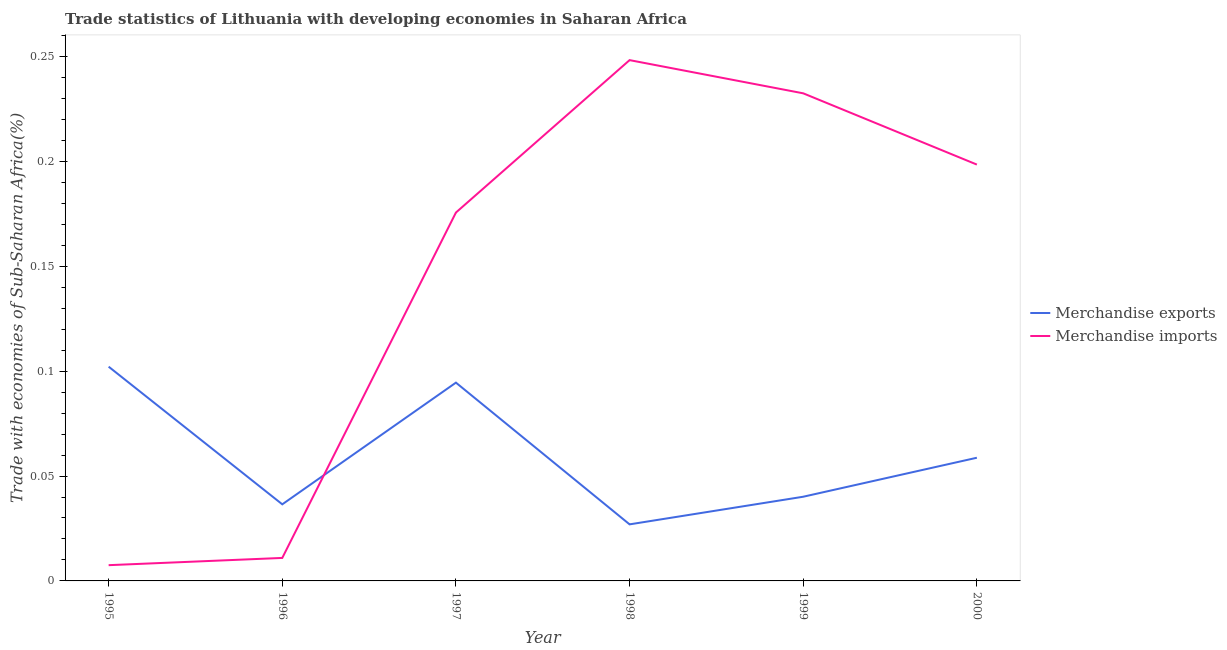How many different coloured lines are there?
Provide a short and direct response. 2. What is the merchandise exports in 1999?
Your answer should be very brief. 0.04. Across all years, what is the maximum merchandise imports?
Offer a terse response. 0.25. Across all years, what is the minimum merchandise exports?
Offer a terse response. 0.03. In which year was the merchandise exports minimum?
Give a very brief answer. 1998. What is the total merchandise exports in the graph?
Give a very brief answer. 0.36. What is the difference between the merchandise imports in 1995 and that in 1997?
Your answer should be compact. -0.17. What is the difference between the merchandise imports in 2000 and the merchandise exports in 1996?
Provide a succinct answer. 0.16. What is the average merchandise exports per year?
Make the answer very short. 0.06. In the year 2000, what is the difference between the merchandise imports and merchandise exports?
Offer a very short reply. 0.14. In how many years, is the merchandise exports greater than 0.22 %?
Your answer should be compact. 0. What is the ratio of the merchandise exports in 1997 to that in 1998?
Provide a succinct answer. 3.51. What is the difference between the highest and the second highest merchandise imports?
Ensure brevity in your answer.  0.02. What is the difference between the highest and the lowest merchandise imports?
Make the answer very short. 0.24. In how many years, is the merchandise exports greater than the average merchandise exports taken over all years?
Your answer should be very brief. 2. Is the sum of the merchandise imports in 1999 and 2000 greater than the maximum merchandise exports across all years?
Make the answer very short. Yes. Does the merchandise exports monotonically increase over the years?
Keep it short and to the point. No. Is the merchandise exports strictly greater than the merchandise imports over the years?
Make the answer very short. No. Is the merchandise exports strictly less than the merchandise imports over the years?
Offer a very short reply. No. How many years are there in the graph?
Your answer should be compact. 6. What is the difference between two consecutive major ticks on the Y-axis?
Your answer should be very brief. 0.05. Where does the legend appear in the graph?
Offer a terse response. Center right. How many legend labels are there?
Provide a short and direct response. 2. What is the title of the graph?
Ensure brevity in your answer.  Trade statistics of Lithuania with developing economies in Saharan Africa. Does "International Visitors" appear as one of the legend labels in the graph?
Offer a very short reply. No. What is the label or title of the X-axis?
Provide a short and direct response. Year. What is the label or title of the Y-axis?
Your answer should be compact. Trade with economies of Sub-Saharan Africa(%). What is the Trade with economies of Sub-Saharan Africa(%) in Merchandise exports in 1995?
Your answer should be compact. 0.1. What is the Trade with economies of Sub-Saharan Africa(%) in Merchandise imports in 1995?
Offer a very short reply. 0.01. What is the Trade with economies of Sub-Saharan Africa(%) of Merchandise exports in 1996?
Offer a very short reply. 0.04. What is the Trade with economies of Sub-Saharan Africa(%) of Merchandise imports in 1996?
Your response must be concise. 0.01. What is the Trade with economies of Sub-Saharan Africa(%) of Merchandise exports in 1997?
Your answer should be compact. 0.09. What is the Trade with economies of Sub-Saharan Africa(%) of Merchandise imports in 1997?
Ensure brevity in your answer.  0.18. What is the Trade with economies of Sub-Saharan Africa(%) of Merchandise exports in 1998?
Provide a short and direct response. 0.03. What is the Trade with economies of Sub-Saharan Africa(%) of Merchandise imports in 1998?
Your response must be concise. 0.25. What is the Trade with economies of Sub-Saharan Africa(%) of Merchandise exports in 1999?
Your answer should be compact. 0.04. What is the Trade with economies of Sub-Saharan Africa(%) in Merchandise imports in 1999?
Your answer should be very brief. 0.23. What is the Trade with economies of Sub-Saharan Africa(%) in Merchandise exports in 2000?
Offer a terse response. 0.06. What is the Trade with economies of Sub-Saharan Africa(%) of Merchandise imports in 2000?
Ensure brevity in your answer.  0.2. Across all years, what is the maximum Trade with economies of Sub-Saharan Africa(%) in Merchandise exports?
Keep it short and to the point. 0.1. Across all years, what is the maximum Trade with economies of Sub-Saharan Africa(%) in Merchandise imports?
Your response must be concise. 0.25. Across all years, what is the minimum Trade with economies of Sub-Saharan Africa(%) of Merchandise exports?
Ensure brevity in your answer.  0.03. Across all years, what is the minimum Trade with economies of Sub-Saharan Africa(%) in Merchandise imports?
Your answer should be very brief. 0.01. What is the total Trade with economies of Sub-Saharan Africa(%) in Merchandise exports in the graph?
Provide a short and direct response. 0.36. What is the total Trade with economies of Sub-Saharan Africa(%) in Merchandise imports in the graph?
Give a very brief answer. 0.87. What is the difference between the Trade with economies of Sub-Saharan Africa(%) of Merchandise exports in 1995 and that in 1996?
Your response must be concise. 0.07. What is the difference between the Trade with economies of Sub-Saharan Africa(%) in Merchandise imports in 1995 and that in 1996?
Your answer should be compact. -0. What is the difference between the Trade with economies of Sub-Saharan Africa(%) of Merchandise exports in 1995 and that in 1997?
Make the answer very short. 0.01. What is the difference between the Trade with economies of Sub-Saharan Africa(%) in Merchandise imports in 1995 and that in 1997?
Provide a short and direct response. -0.17. What is the difference between the Trade with economies of Sub-Saharan Africa(%) of Merchandise exports in 1995 and that in 1998?
Provide a short and direct response. 0.08. What is the difference between the Trade with economies of Sub-Saharan Africa(%) in Merchandise imports in 1995 and that in 1998?
Provide a short and direct response. -0.24. What is the difference between the Trade with economies of Sub-Saharan Africa(%) in Merchandise exports in 1995 and that in 1999?
Give a very brief answer. 0.06. What is the difference between the Trade with economies of Sub-Saharan Africa(%) in Merchandise imports in 1995 and that in 1999?
Your response must be concise. -0.22. What is the difference between the Trade with economies of Sub-Saharan Africa(%) in Merchandise exports in 1995 and that in 2000?
Your response must be concise. 0.04. What is the difference between the Trade with economies of Sub-Saharan Africa(%) of Merchandise imports in 1995 and that in 2000?
Give a very brief answer. -0.19. What is the difference between the Trade with economies of Sub-Saharan Africa(%) of Merchandise exports in 1996 and that in 1997?
Provide a succinct answer. -0.06. What is the difference between the Trade with economies of Sub-Saharan Africa(%) in Merchandise imports in 1996 and that in 1997?
Provide a short and direct response. -0.16. What is the difference between the Trade with economies of Sub-Saharan Africa(%) in Merchandise exports in 1996 and that in 1998?
Provide a succinct answer. 0.01. What is the difference between the Trade with economies of Sub-Saharan Africa(%) of Merchandise imports in 1996 and that in 1998?
Offer a terse response. -0.24. What is the difference between the Trade with economies of Sub-Saharan Africa(%) of Merchandise exports in 1996 and that in 1999?
Your answer should be very brief. -0. What is the difference between the Trade with economies of Sub-Saharan Africa(%) of Merchandise imports in 1996 and that in 1999?
Keep it short and to the point. -0.22. What is the difference between the Trade with economies of Sub-Saharan Africa(%) of Merchandise exports in 1996 and that in 2000?
Provide a succinct answer. -0.02. What is the difference between the Trade with economies of Sub-Saharan Africa(%) of Merchandise imports in 1996 and that in 2000?
Provide a short and direct response. -0.19. What is the difference between the Trade with economies of Sub-Saharan Africa(%) of Merchandise exports in 1997 and that in 1998?
Offer a terse response. 0.07. What is the difference between the Trade with economies of Sub-Saharan Africa(%) in Merchandise imports in 1997 and that in 1998?
Make the answer very short. -0.07. What is the difference between the Trade with economies of Sub-Saharan Africa(%) in Merchandise exports in 1997 and that in 1999?
Offer a very short reply. 0.05. What is the difference between the Trade with economies of Sub-Saharan Africa(%) of Merchandise imports in 1997 and that in 1999?
Offer a very short reply. -0.06. What is the difference between the Trade with economies of Sub-Saharan Africa(%) in Merchandise exports in 1997 and that in 2000?
Your response must be concise. 0.04. What is the difference between the Trade with economies of Sub-Saharan Africa(%) in Merchandise imports in 1997 and that in 2000?
Your answer should be very brief. -0.02. What is the difference between the Trade with economies of Sub-Saharan Africa(%) of Merchandise exports in 1998 and that in 1999?
Give a very brief answer. -0.01. What is the difference between the Trade with economies of Sub-Saharan Africa(%) in Merchandise imports in 1998 and that in 1999?
Your answer should be compact. 0.02. What is the difference between the Trade with economies of Sub-Saharan Africa(%) of Merchandise exports in 1998 and that in 2000?
Your answer should be compact. -0.03. What is the difference between the Trade with economies of Sub-Saharan Africa(%) of Merchandise imports in 1998 and that in 2000?
Give a very brief answer. 0.05. What is the difference between the Trade with economies of Sub-Saharan Africa(%) in Merchandise exports in 1999 and that in 2000?
Your answer should be very brief. -0.02. What is the difference between the Trade with economies of Sub-Saharan Africa(%) in Merchandise imports in 1999 and that in 2000?
Your answer should be very brief. 0.03. What is the difference between the Trade with economies of Sub-Saharan Africa(%) in Merchandise exports in 1995 and the Trade with economies of Sub-Saharan Africa(%) in Merchandise imports in 1996?
Ensure brevity in your answer.  0.09. What is the difference between the Trade with economies of Sub-Saharan Africa(%) in Merchandise exports in 1995 and the Trade with economies of Sub-Saharan Africa(%) in Merchandise imports in 1997?
Your response must be concise. -0.07. What is the difference between the Trade with economies of Sub-Saharan Africa(%) in Merchandise exports in 1995 and the Trade with economies of Sub-Saharan Africa(%) in Merchandise imports in 1998?
Offer a very short reply. -0.15. What is the difference between the Trade with economies of Sub-Saharan Africa(%) of Merchandise exports in 1995 and the Trade with economies of Sub-Saharan Africa(%) of Merchandise imports in 1999?
Give a very brief answer. -0.13. What is the difference between the Trade with economies of Sub-Saharan Africa(%) in Merchandise exports in 1995 and the Trade with economies of Sub-Saharan Africa(%) in Merchandise imports in 2000?
Provide a short and direct response. -0.1. What is the difference between the Trade with economies of Sub-Saharan Africa(%) in Merchandise exports in 1996 and the Trade with economies of Sub-Saharan Africa(%) in Merchandise imports in 1997?
Offer a very short reply. -0.14. What is the difference between the Trade with economies of Sub-Saharan Africa(%) of Merchandise exports in 1996 and the Trade with economies of Sub-Saharan Africa(%) of Merchandise imports in 1998?
Offer a terse response. -0.21. What is the difference between the Trade with economies of Sub-Saharan Africa(%) of Merchandise exports in 1996 and the Trade with economies of Sub-Saharan Africa(%) of Merchandise imports in 1999?
Make the answer very short. -0.2. What is the difference between the Trade with economies of Sub-Saharan Africa(%) in Merchandise exports in 1996 and the Trade with economies of Sub-Saharan Africa(%) in Merchandise imports in 2000?
Make the answer very short. -0.16. What is the difference between the Trade with economies of Sub-Saharan Africa(%) in Merchandise exports in 1997 and the Trade with economies of Sub-Saharan Africa(%) in Merchandise imports in 1998?
Make the answer very short. -0.15. What is the difference between the Trade with economies of Sub-Saharan Africa(%) of Merchandise exports in 1997 and the Trade with economies of Sub-Saharan Africa(%) of Merchandise imports in 1999?
Offer a terse response. -0.14. What is the difference between the Trade with economies of Sub-Saharan Africa(%) in Merchandise exports in 1997 and the Trade with economies of Sub-Saharan Africa(%) in Merchandise imports in 2000?
Ensure brevity in your answer.  -0.1. What is the difference between the Trade with economies of Sub-Saharan Africa(%) of Merchandise exports in 1998 and the Trade with economies of Sub-Saharan Africa(%) of Merchandise imports in 1999?
Your response must be concise. -0.21. What is the difference between the Trade with economies of Sub-Saharan Africa(%) in Merchandise exports in 1998 and the Trade with economies of Sub-Saharan Africa(%) in Merchandise imports in 2000?
Ensure brevity in your answer.  -0.17. What is the difference between the Trade with economies of Sub-Saharan Africa(%) of Merchandise exports in 1999 and the Trade with economies of Sub-Saharan Africa(%) of Merchandise imports in 2000?
Your answer should be compact. -0.16. What is the average Trade with economies of Sub-Saharan Africa(%) of Merchandise exports per year?
Your answer should be compact. 0.06. What is the average Trade with economies of Sub-Saharan Africa(%) in Merchandise imports per year?
Your answer should be compact. 0.15. In the year 1995, what is the difference between the Trade with economies of Sub-Saharan Africa(%) of Merchandise exports and Trade with economies of Sub-Saharan Africa(%) of Merchandise imports?
Make the answer very short. 0.09. In the year 1996, what is the difference between the Trade with economies of Sub-Saharan Africa(%) of Merchandise exports and Trade with economies of Sub-Saharan Africa(%) of Merchandise imports?
Provide a short and direct response. 0.03. In the year 1997, what is the difference between the Trade with economies of Sub-Saharan Africa(%) of Merchandise exports and Trade with economies of Sub-Saharan Africa(%) of Merchandise imports?
Provide a short and direct response. -0.08. In the year 1998, what is the difference between the Trade with economies of Sub-Saharan Africa(%) in Merchandise exports and Trade with economies of Sub-Saharan Africa(%) in Merchandise imports?
Give a very brief answer. -0.22. In the year 1999, what is the difference between the Trade with economies of Sub-Saharan Africa(%) in Merchandise exports and Trade with economies of Sub-Saharan Africa(%) in Merchandise imports?
Provide a short and direct response. -0.19. In the year 2000, what is the difference between the Trade with economies of Sub-Saharan Africa(%) of Merchandise exports and Trade with economies of Sub-Saharan Africa(%) of Merchandise imports?
Make the answer very short. -0.14. What is the ratio of the Trade with economies of Sub-Saharan Africa(%) of Merchandise exports in 1995 to that in 1996?
Offer a terse response. 2.8. What is the ratio of the Trade with economies of Sub-Saharan Africa(%) of Merchandise imports in 1995 to that in 1996?
Ensure brevity in your answer.  0.68. What is the ratio of the Trade with economies of Sub-Saharan Africa(%) of Merchandise exports in 1995 to that in 1997?
Offer a terse response. 1.08. What is the ratio of the Trade with economies of Sub-Saharan Africa(%) of Merchandise imports in 1995 to that in 1997?
Your answer should be very brief. 0.04. What is the ratio of the Trade with economies of Sub-Saharan Africa(%) in Merchandise exports in 1995 to that in 1998?
Give a very brief answer. 3.79. What is the ratio of the Trade with economies of Sub-Saharan Africa(%) of Merchandise imports in 1995 to that in 1998?
Ensure brevity in your answer.  0.03. What is the ratio of the Trade with economies of Sub-Saharan Africa(%) of Merchandise exports in 1995 to that in 1999?
Offer a very short reply. 2.54. What is the ratio of the Trade with economies of Sub-Saharan Africa(%) of Merchandise imports in 1995 to that in 1999?
Offer a very short reply. 0.03. What is the ratio of the Trade with economies of Sub-Saharan Africa(%) of Merchandise exports in 1995 to that in 2000?
Give a very brief answer. 1.74. What is the ratio of the Trade with economies of Sub-Saharan Africa(%) of Merchandise imports in 1995 to that in 2000?
Your answer should be compact. 0.04. What is the ratio of the Trade with economies of Sub-Saharan Africa(%) of Merchandise exports in 1996 to that in 1997?
Your answer should be compact. 0.39. What is the ratio of the Trade with economies of Sub-Saharan Africa(%) in Merchandise imports in 1996 to that in 1997?
Give a very brief answer. 0.06. What is the ratio of the Trade with economies of Sub-Saharan Africa(%) of Merchandise exports in 1996 to that in 1998?
Provide a short and direct response. 1.35. What is the ratio of the Trade with economies of Sub-Saharan Africa(%) in Merchandise imports in 1996 to that in 1998?
Offer a terse response. 0.04. What is the ratio of the Trade with economies of Sub-Saharan Africa(%) of Merchandise exports in 1996 to that in 1999?
Ensure brevity in your answer.  0.91. What is the ratio of the Trade with economies of Sub-Saharan Africa(%) of Merchandise imports in 1996 to that in 1999?
Offer a terse response. 0.05. What is the ratio of the Trade with economies of Sub-Saharan Africa(%) of Merchandise exports in 1996 to that in 2000?
Make the answer very short. 0.62. What is the ratio of the Trade with economies of Sub-Saharan Africa(%) in Merchandise imports in 1996 to that in 2000?
Make the answer very short. 0.06. What is the ratio of the Trade with economies of Sub-Saharan Africa(%) of Merchandise exports in 1997 to that in 1998?
Provide a short and direct response. 3.51. What is the ratio of the Trade with economies of Sub-Saharan Africa(%) of Merchandise imports in 1997 to that in 1998?
Your answer should be very brief. 0.71. What is the ratio of the Trade with economies of Sub-Saharan Africa(%) of Merchandise exports in 1997 to that in 1999?
Provide a short and direct response. 2.36. What is the ratio of the Trade with economies of Sub-Saharan Africa(%) of Merchandise imports in 1997 to that in 1999?
Offer a very short reply. 0.76. What is the ratio of the Trade with economies of Sub-Saharan Africa(%) of Merchandise exports in 1997 to that in 2000?
Provide a succinct answer. 1.61. What is the ratio of the Trade with economies of Sub-Saharan Africa(%) of Merchandise imports in 1997 to that in 2000?
Provide a short and direct response. 0.88. What is the ratio of the Trade with economies of Sub-Saharan Africa(%) of Merchandise exports in 1998 to that in 1999?
Give a very brief answer. 0.67. What is the ratio of the Trade with economies of Sub-Saharan Africa(%) in Merchandise imports in 1998 to that in 1999?
Keep it short and to the point. 1.07. What is the ratio of the Trade with economies of Sub-Saharan Africa(%) in Merchandise exports in 1998 to that in 2000?
Keep it short and to the point. 0.46. What is the ratio of the Trade with economies of Sub-Saharan Africa(%) of Merchandise imports in 1998 to that in 2000?
Provide a short and direct response. 1.25. What is the ratio of the Trade with economies of Sub-Saharan Africa(%) in Merchandise exports in 1999 to that in 2000?
Provide a succinct answer. 0.68. What is the ratio of the Trade with economies of Sub-Saharan Africa(%) in Merchandise imports in 1999 to that in 2000?
Ensure brevity in your answer.  1.17. What is the difference between the highest and the second highest Trade with economies of Sub-Saharan Africa(%) of Merchandise exports?
Provide a short and direct response. 0.01. What is the difference between the highest and the second highest Trade with economies of Sub-Saharan Africa(%) in Merchandise imports?
Your answer should be compact. 0.02. What is the difference between the highest and the lowest Trade with economies of Sub-Saharan Africa(%) in Merchandise exports?
Your response must be concise. 0.08. What is the difference between the highest and the lowest Trade with economies of Sub-Saharan Africa(%) in Merchandise imports?
Provide a short and direct response. 0.24. 